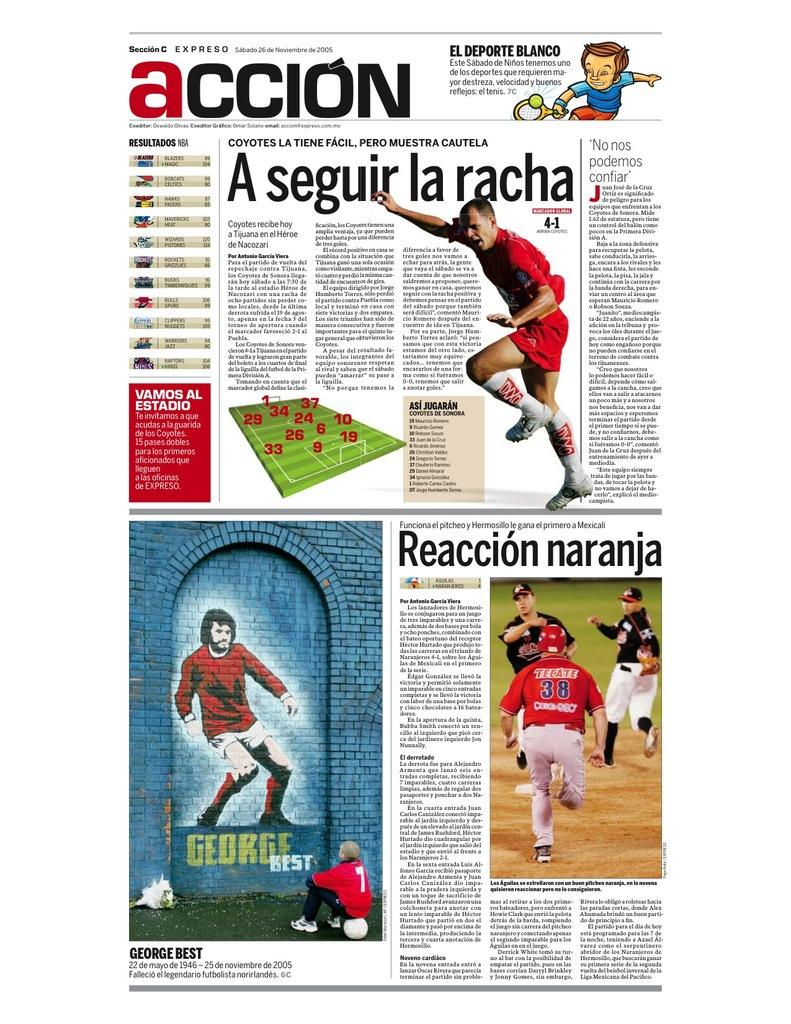<image>
Describe the image concisely. Article that has the word ACCION on the top. 